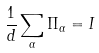Convert formula to latex. <formula><loc_0><loc_0><loc_500><loc_500>\frac { 1 } { d } \sum _ { \alpha } \Pi _ { \alpha } = I</formula> 